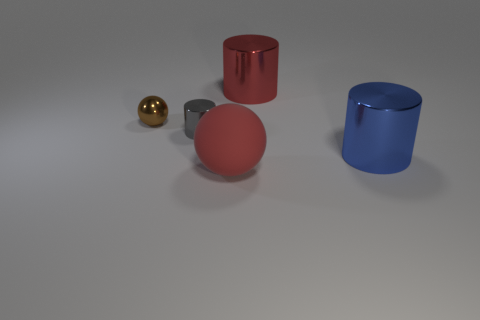Is there any other thing that is the same size as the rubber object?
Provide a short and direct response. Yes. Are there fewer large metallic things that are right of the brown metallic sphere than gray objects that are behind the small cylinder?
Provide a succinct answer. No. Do the sphere that is to the right of the gray shiny object and the big cylinder behind the gray object have the same color?
Your answer should be very brief. Yes. What is the object that is right of the big red sphere and behind the small gray cylinder made of?
Provide a succinct answer. Metal. Are there any big red rubber cubes?
Your response must be concise. No. There is a brown thing that is made of the same material as the big blue thing; what shape is it?
Your response must be concise. Sphere. Is the shape of the tiny gray metallic object the same as the red object right of the big matte sphere?
Make the answer very short. Yes. What material is the red thing that is in front of the large cylinder that is behind the brown ball?
Your answer should be compact. Rubber. What number of other things are there of the same shape as the gray metal object?
Your answer should be compact. 2. Does the red thing that is in front of the blue metal thing have the same shape as the brown thing to the left of the matte thing?
Provide a succinct answer. Yes. 